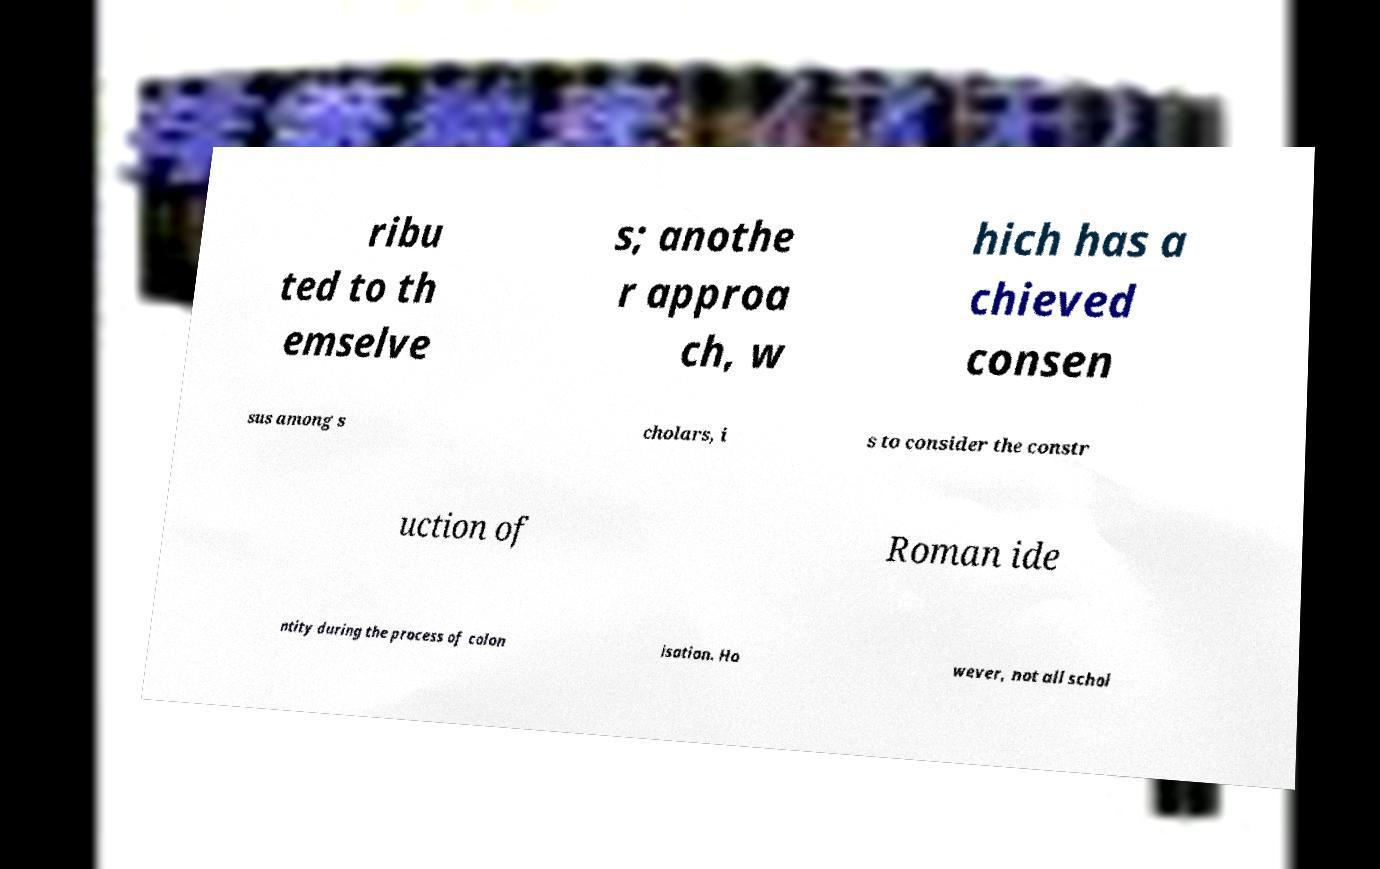Could you assist in decoding the text presented in this image and type it out clearly? ribu ted to th emselve s; anothe r approa ch, w hich has a chieved consen sus among s cholars, i s to consider the constr uction of Roman ide ntity during the process of colon isation. Ho wever, not all schol 